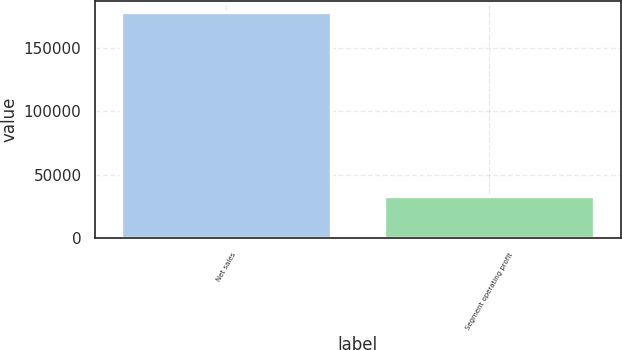<chart> <loc_0><loc_0><loc_500><loc_500><bar_chart><fcel>Net sales<fcel>Segment operating profit<nl><fcel>177945<fcel>32859<nl></chart> 